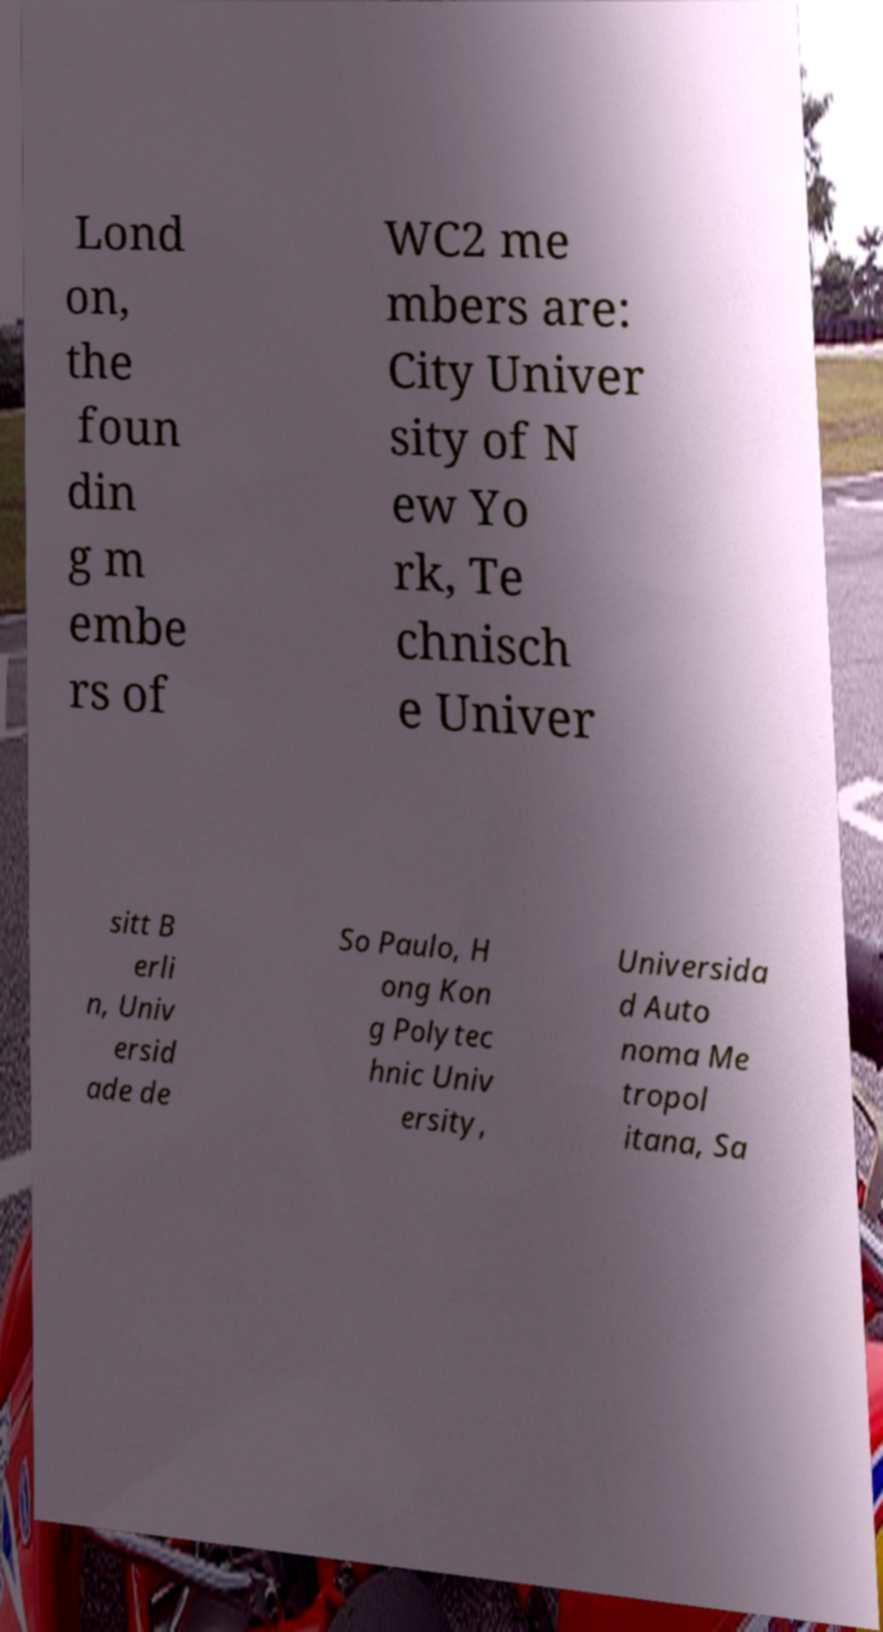Could you extract and type out the text from this image? Lond on, the foun din g m embe rs of WC2 me mbers are: City Univer sity of N ew Yo rk, Te chnisch e Univer sitt B erli n, Univ ersid ade de So Paulo, H ong Kon g Polytec hnic Univ ersity, Universida d Auto noma Me tropol itana, Sa 